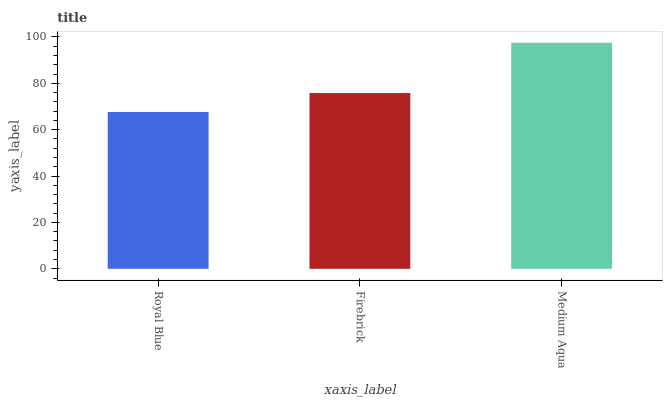Is Firebrick the minimum?
Answer yes or no. No. Is Firebrick the maximum?
Answer yes or no. No. Is Firebrick greater than Royal Blue?
Answer yes or no. Yes. Is Royal Blue less than Firebrick?
Answer yes or no. Yes. Is Royal Blue greater than Firebrick?
Answer yes or no. No. Is Firebrick less than Royal Blue?
Answer yes or no. No. Is Firebrick the high median?
Answer yes or no. Yes. Is Firebrick the low median?
Answer yes or no. Yes. Is Royal Blue the high median?
Answer yes or no. No. Is Medium Aqua the low median?
Answer yes or no. No. 